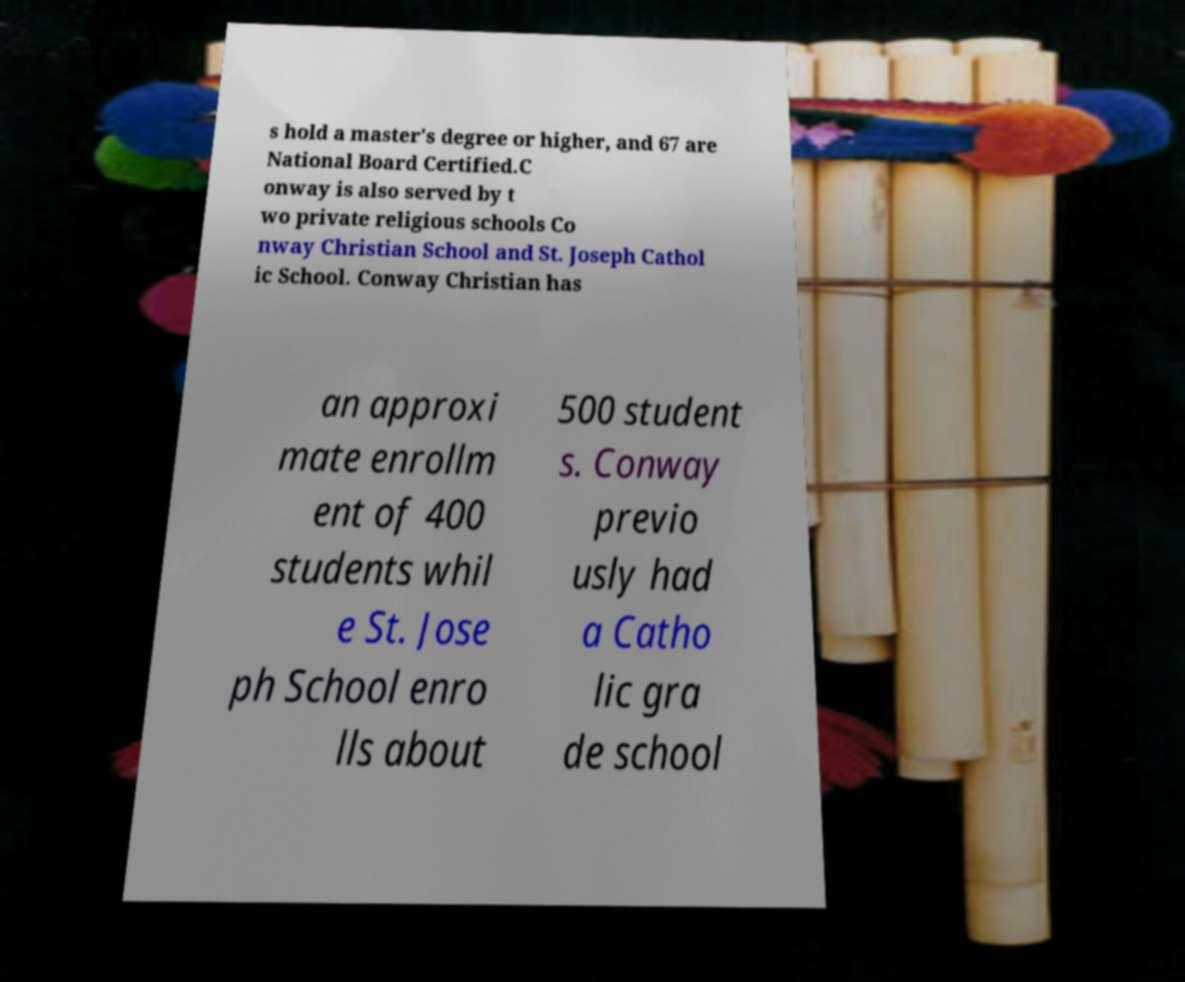Can you read and provide the text displayed in the image?This photo seems to have some interesting text. Can you extract and type it out for me? s hold a master's degree or higher, and 67 are National Board Certified.C onway is also served by t wo private religious schools Co nway Christian School and St. Joseph Cathol ic School. Conway Christian has an approxi mate enrollm ent of 400 students whil e St. Jose ph School enro lls about 500 student s. Conway previo usly had a Catho lic gra de school 